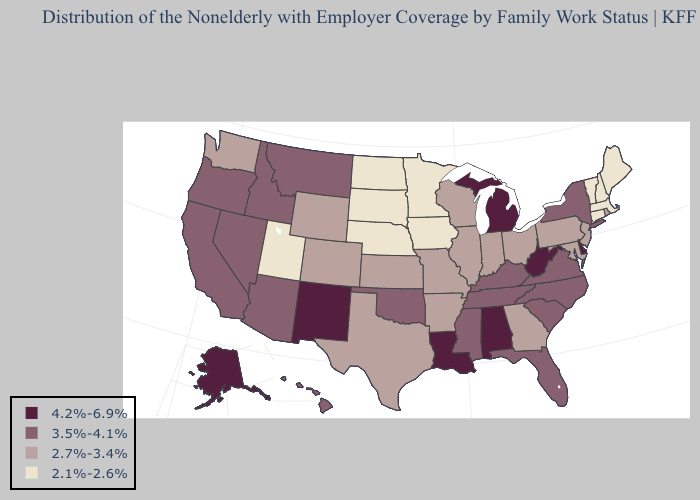Name the states that have a value in the range 2.1%-2.6%?
Write a very short answer. Connecticut, Iowa, Maine, Massachusetts, Minnesota, Nebraska, New Hampshire, North Dakota, South Dakota, Utah, Vermont. Does Mississippi have the highest value in the South?
Short answer required. No. Name the states that have a value in the range 2.1%-2.6%?
Quick response, please. Connecticut, Iowa, Maine, Massachusetts, Minnesota, Nebraska, New Hampshire, North Dakota, South Dakota, Utah, Vermont. What is the value of Mississippi?
Concise answer only. 3.5%-4.1%. Is the legend a continuous bar?
Quick response, please. No. What is the lowest value in states that border Oklahoma?
Answer briefly. 2.7%-3.4%. Name the states that have a value in the range 4.2%-6.9%?
Be succinct. Alabama, Alaska, Delaware, Louisiana, Michigan, New Mexico, West Virginia. What is the value of Kentucky?
Write a very short answer. 3.5%-4.1%. Name the states that have a value in the range 2.7%-3.4%?
Concise answer only. Arkansas, Colorado, Georgia, Illinois, Indiana, Kansas, Maryland, Missouri, New Jersey, Ohio, Pennsylvania, Rhode Island, Texas, Washington, Wisconsin, Wyoming. Which states have the highest value in the USA?
Answer briefly. Alabama, Alaska, Delaware, Louisiana, Michigan, New Mexico, West Virginia. What is the lowest value in the USA?
Be succinct. 2.1%-2.6%. What is the value of Louisiana?
Give a very brief answer. 4.2%-6.9%. What is the value of Arizona?
Write a very short answer. 3.5%-4.1%. Name the states that have a value in the range 3.5%-4.1%?
Write a very short answer. Arizona, California, Florida, Hawaii, Idaho, Kentucky, Mississippi, Montana, Nevada, New York, North Carolina, Oklahoma, Oregon, South Carolina, Tennessee, Virginia. What is the value of Oklahoma?
Short answer required. 3.5%-4.1%. 